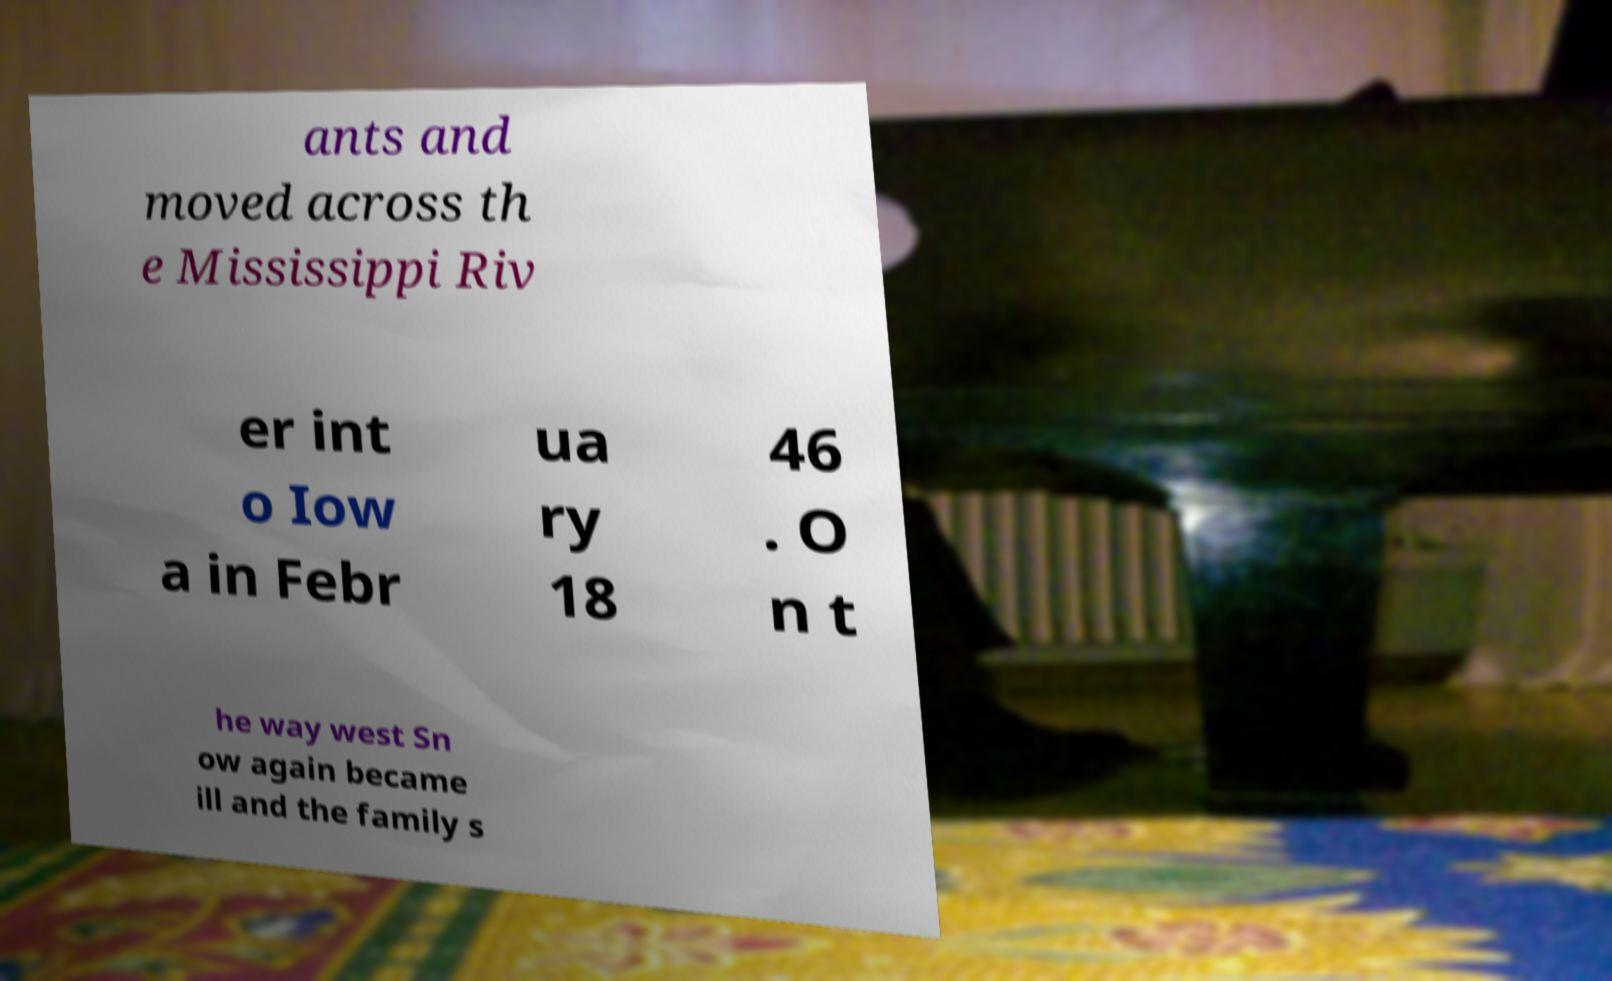Can you read and provide the text displayed in the image?This photo seems to have some interesting text. Can you extract and type it out for me? ants and moved across th e Mississippi Riv er int o Iow a in Febr ua ry 18 46 . O n t he way west Sn ow again became ill and the family s 